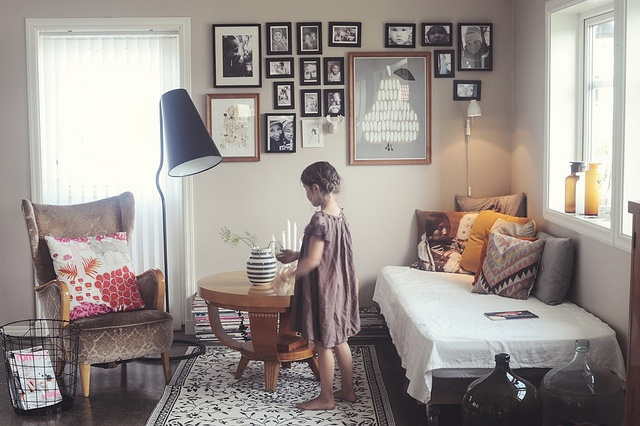Describe the objects in this image and their specific colors. I can see bed in gray, lightgray, darkgray, and black tones, couch in gray, darkgray, and lightgray tones, chair in gray, darkgray, and lightgray tones, people in gray, darkgray, and black tones, and bottle in gray and black tones in this image. 